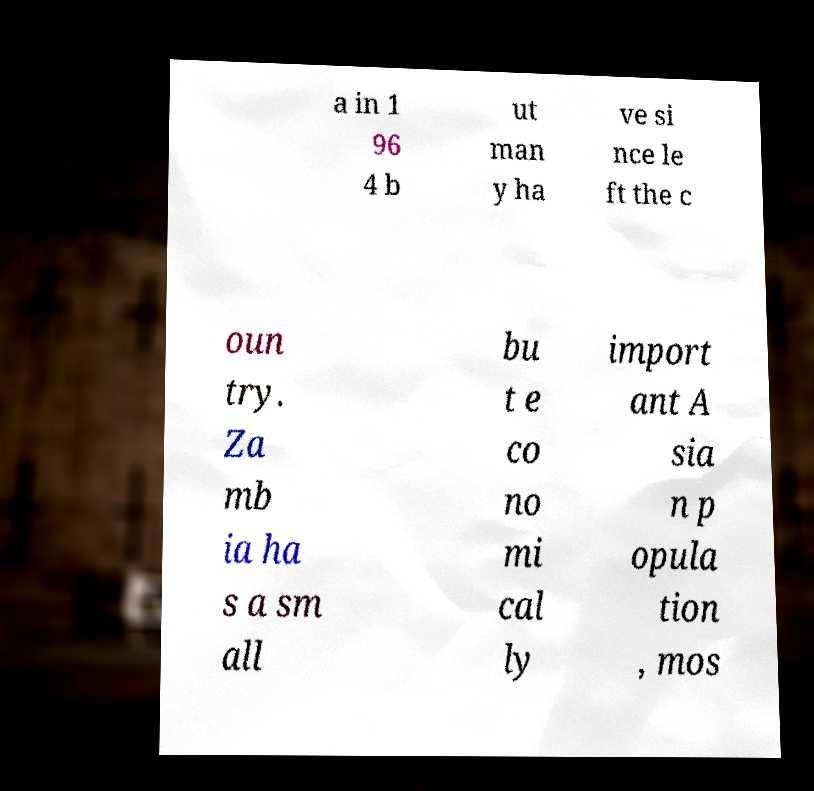Please read and relay the text visible in this image. What does it say? a in 1 96 4 b ut man y ha ve si nce le ft the c oun try. Za mb ia ha s a sm all bu t e co no mi cal ly import ant A sia n p opula tion , mos 